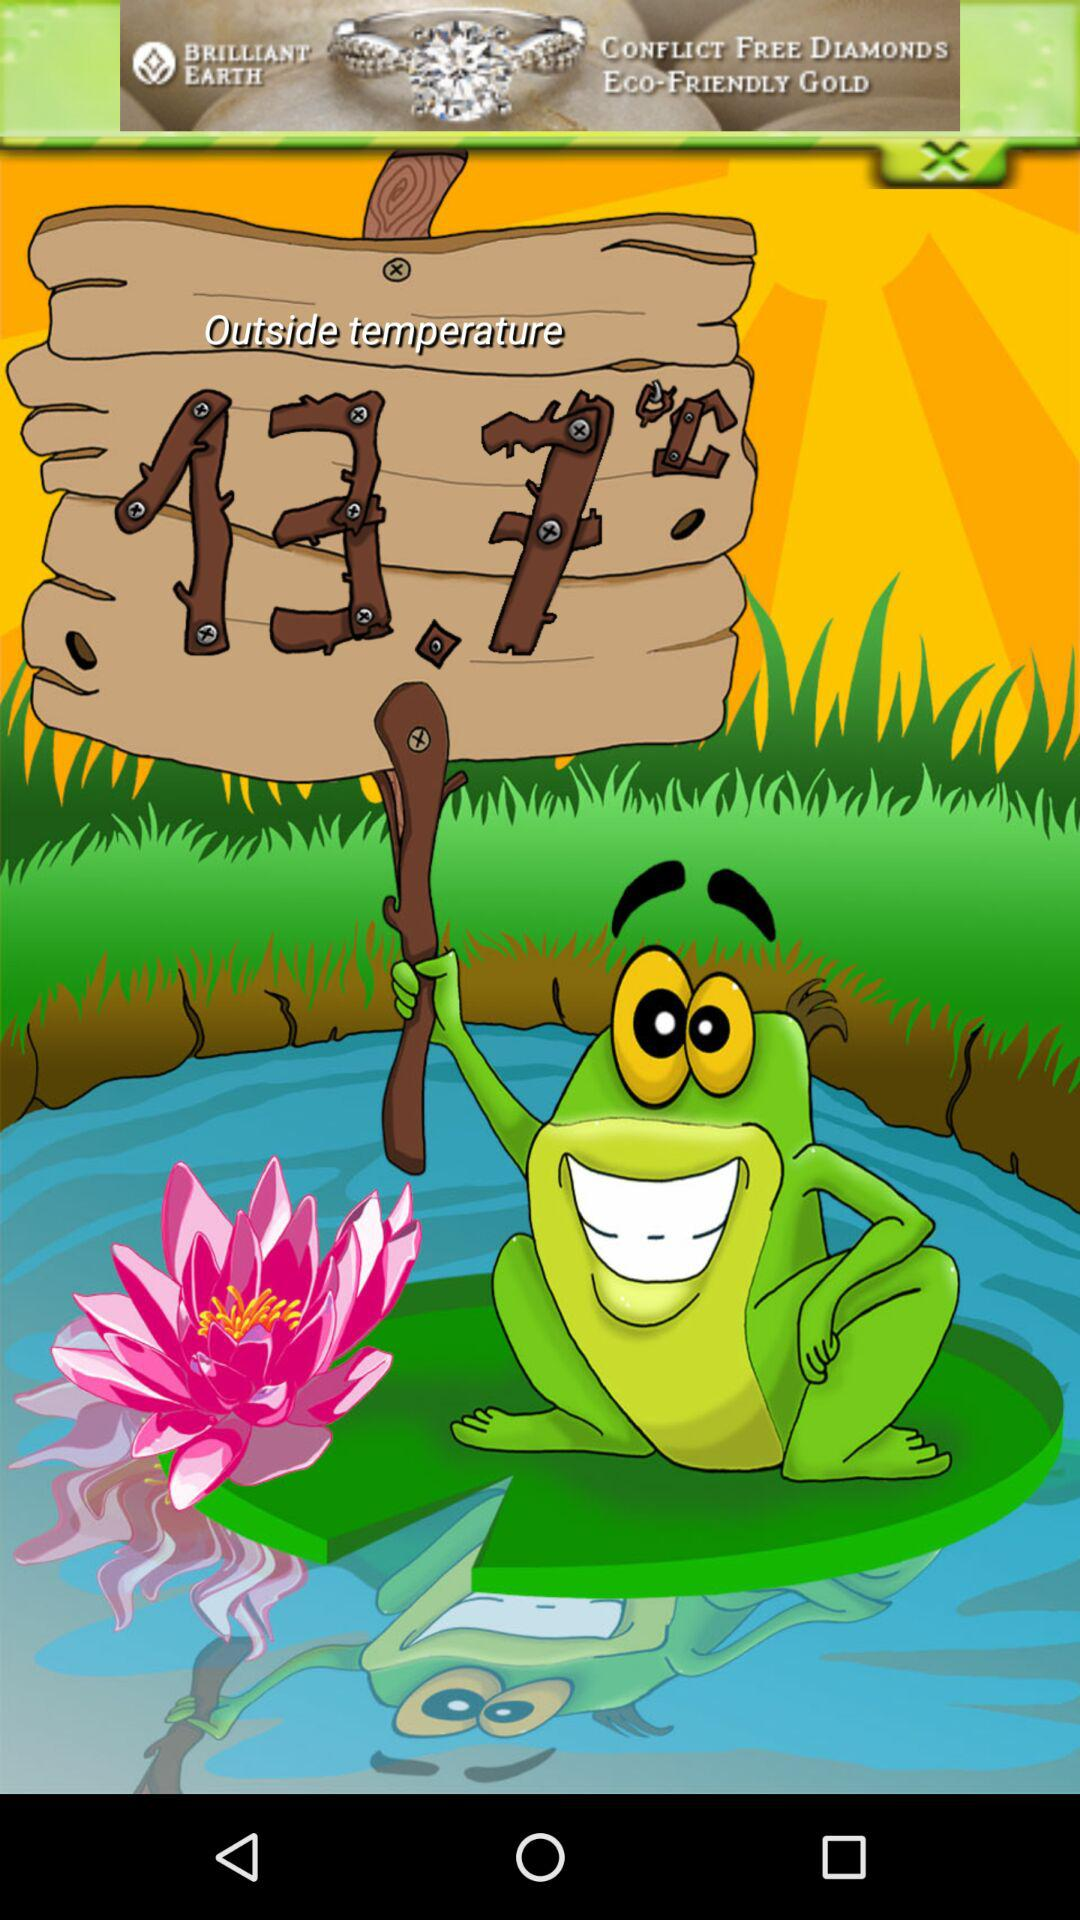What is the outside temperature? The outside temperature is 13.7 °C. 